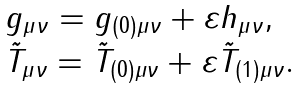<formula> <loc_0><loc_0><loc_500><loc_500>\begin{array} { l l } g _ { \mu \nu } = g _ { ( 0 ) \mu \nu } + \varepsilon h _ { \mu \nu } , \\ \tilde { T } _ { \mu \nu } = \tilde { T } _ { ( 0 ) \mu \nu } + \varepsilon \tilde { T } _ { ( 1 ) \mu \nu } . \end{array}</formula> 